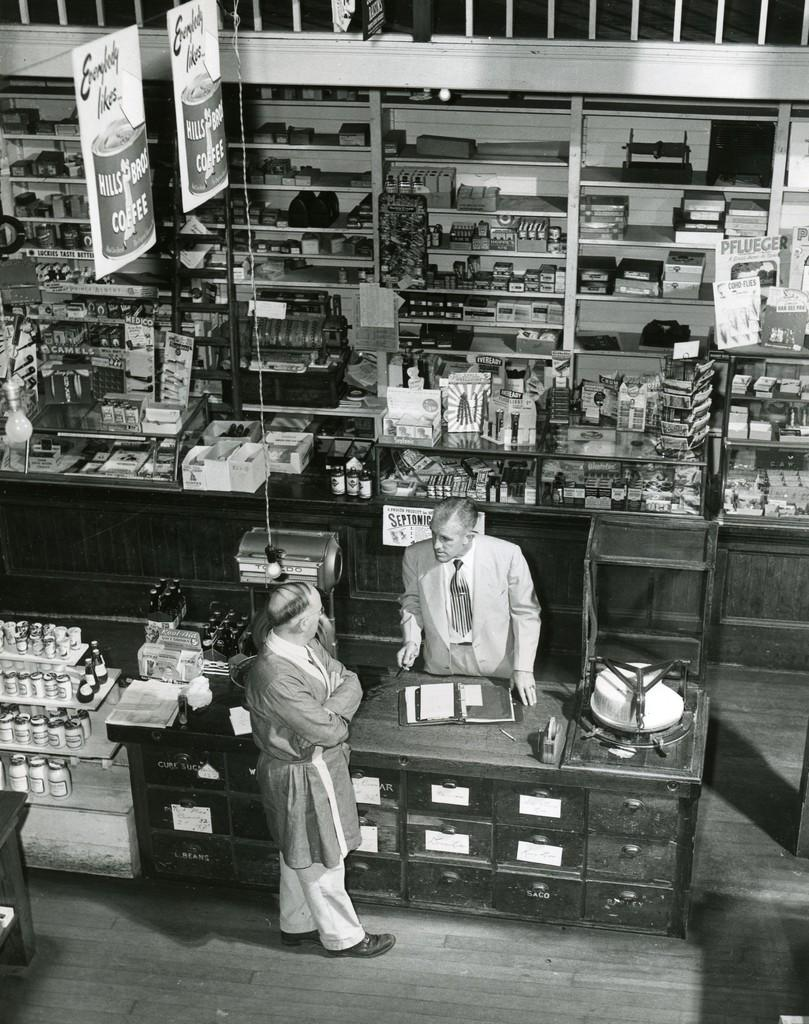<image>
Render a clear and concise summary of the photo. Advertisements for Hills Bros. Coffee hang from the ceiling in a grocery store. 